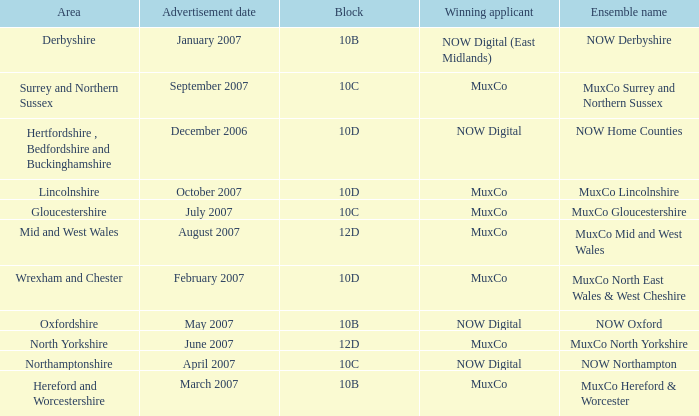Who is the Winning Applicant of Ensemble Name Muxco Lincolnshire in Block 10D? MuxCo. 